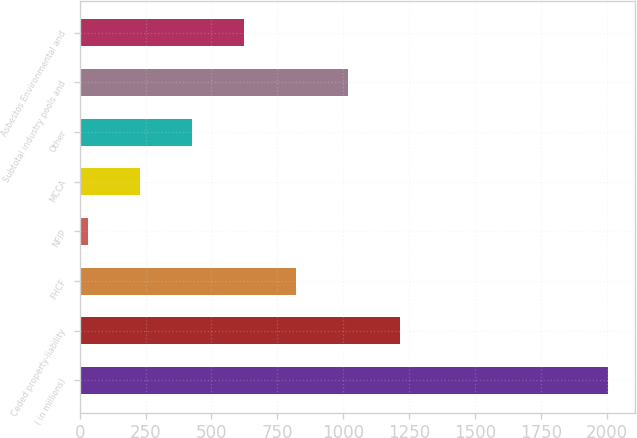Convert chart. <chart><loc_0><loc_0><loc_500><loc_500><bar_chart><fcel>( in millions)<fcel>Ceded property-liability<fcel>FHCF<fcel>NFIP<fcel>MCCA<fcel>Other<fcel>Subtotal industry pools and<fcel>Asbestos Environmental and<nl><fcel>2006<fcel>1216.4<fcel>821.6<fcel>32<fcel>229.4<fcel>426.8<fcel>1019<fcel>624.2<nl></chart> 